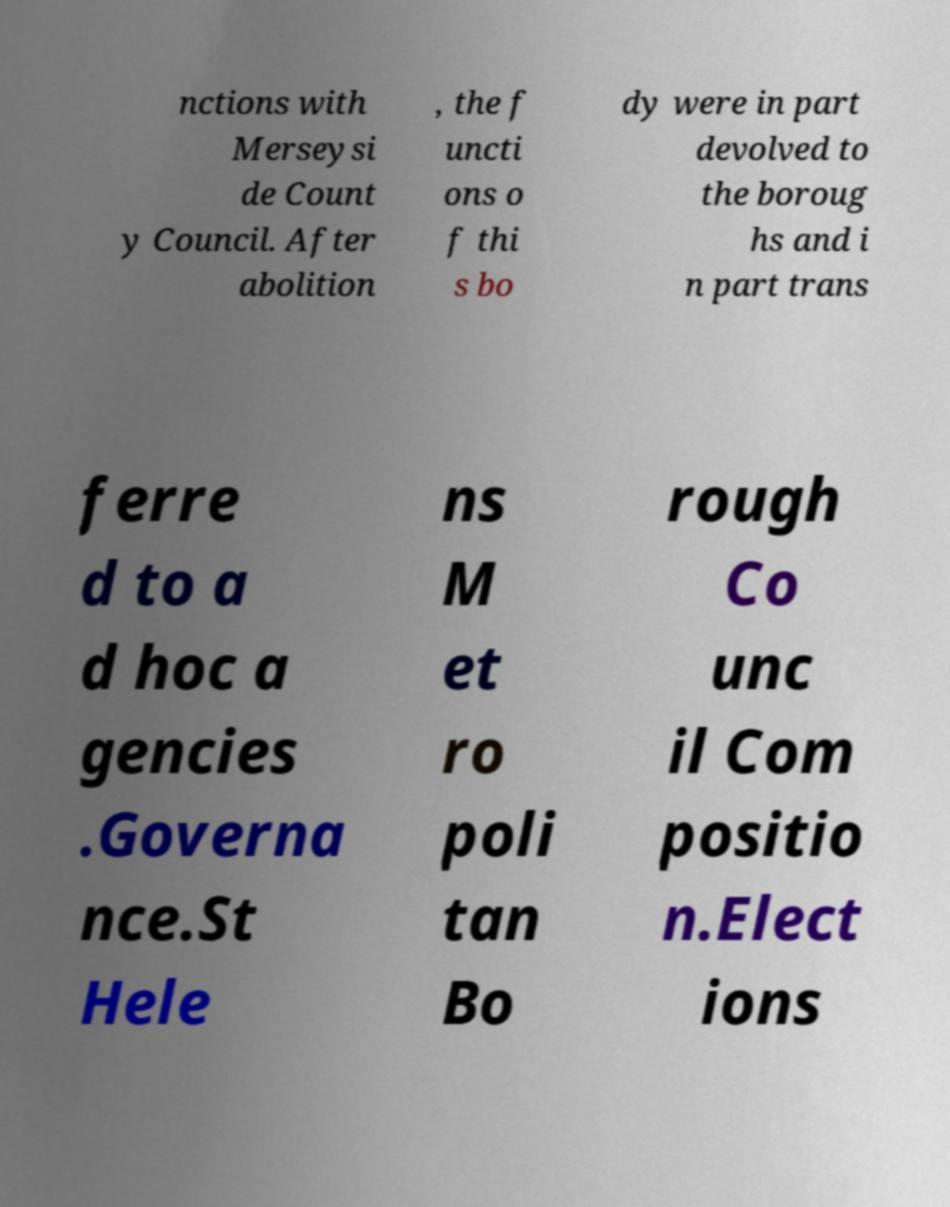Could you extract and type out the text from this image? nctions with Merseysi de Count y Council. After abolition , the f uncti ons o f thi s bo dy were in part devolved to the boroug hs and i n part trans ferre d to a d hoc a gencies .Governa nce.St Hele ns M et ro poli tan Bo rough Co unc il Com positio n.Elect ions 